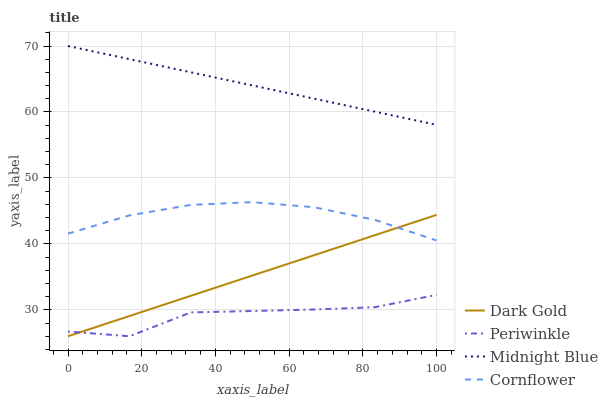Does Periwinkle have the minimum area under the curve?
Answer yes or no. Yes. Does Midnight Blue have the maximum area under the curve?
Answer yes or no. Yes. Does Midnight Blue have the minimum area under the curve?
Answer yes or no. No. Does Periwinkle have the maximum area under the curve?
Answer yes or no. No. Is Dark Gold the smoothest?
Answer yes or no. Yes. Is Periwinkle the roughest?
Answer yes or no. Yes. Is Midnight Blue the smoothest?
Answer yes or no. No. Is Midnight Blue the roughest?
Answer yes or no. No. Does Periwinkle have the lowest value?
Answer yes or no. Yes. Does Midnight Blue have the lowest value?
Answer yes or no. No. Does Midnight Blue have the highest value?
Answer yes or no. Yes. Does Periwinkle have the highest value?
Answer yes or no. No. Is Periwinkle less than Midnight Blue?
Answer yes or no. Yes. Is Midnight Blue greater than Dark Gold?
Answer yes or no. Yes. Does Dark Gold intersect Periwinkle?
Answer yes or no. Yes. Is Dark Gold less than Periwinkle?
Answer yes or no. No. Is Dark Gold greater than Periwinkle?
Answer yes or no. No. Does Periwinkle intersect Midnight Blue?
Answer yes or no. No. 